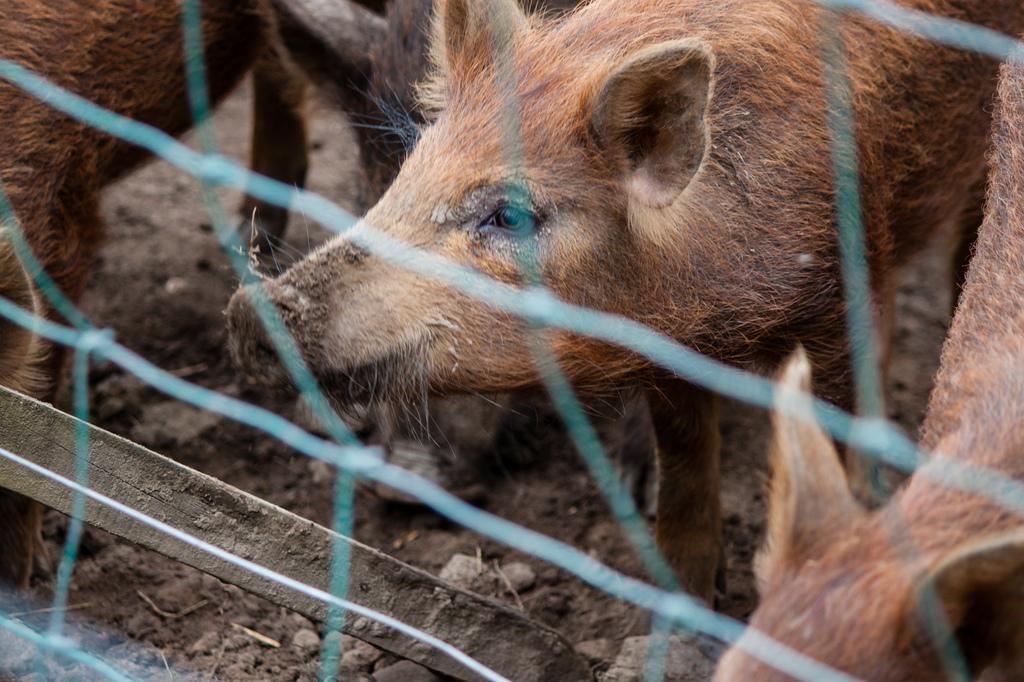Can you describe this image briefly? There is net and there are pigs on the mud. 